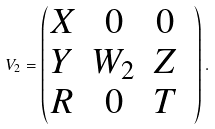Convert formula to latex. <formula><loc_0><loc_0><loc_500><loc_500>V _ { 2 } = \begin{pmatrix} X & 0 & 0 & \\ Y & W _ { 2 } & Z & \\ R & 0 & T & \\ \end{pmatrix} .</formula> 